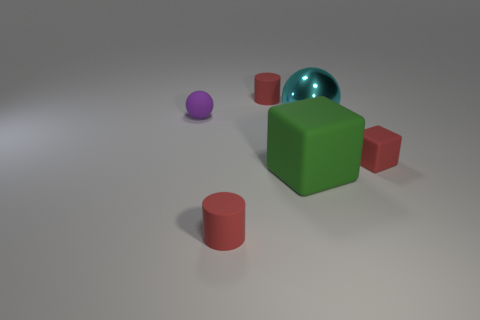Add 1 big metal blocks. How many objects exist? 7 Subtract 0 blue cylinders. How many objects are left? 6 Subtract 2 spheres. How many spheres are left? 0 Subtract all red spheres. Subtract all purple cubes. How many spheres are left? 2 Subtract all green cubes. How many yellow cylinders are left? 0 Subtract all large cyan balls. Subtract all metallic spheres. How many objects are left? 4 Add 1 spheres. How many spheres are left? 3 Add 3 small red rubber blocks. How many small red rubber blocks exist? 4 